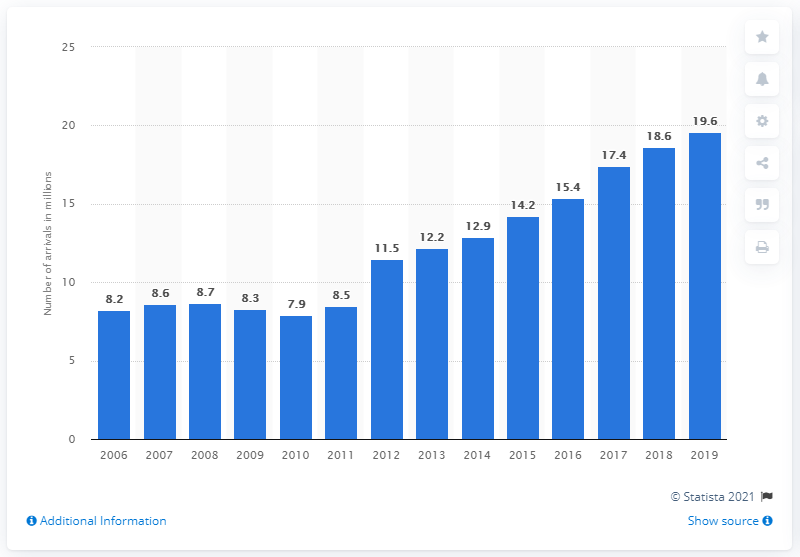Highlight a few significant elements in this photo. In 2019, a total of 19,600 tourists arrived at accommodation establishments in Croatia. 